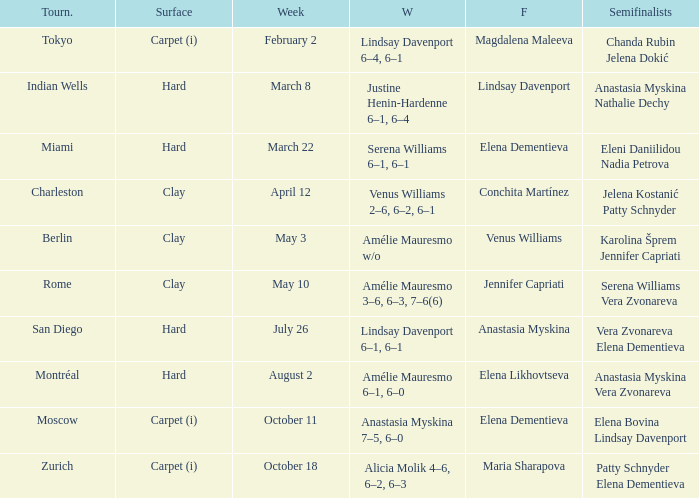Who was the finalist of the hard surface tournament in Miami? Elena Dementieva. 